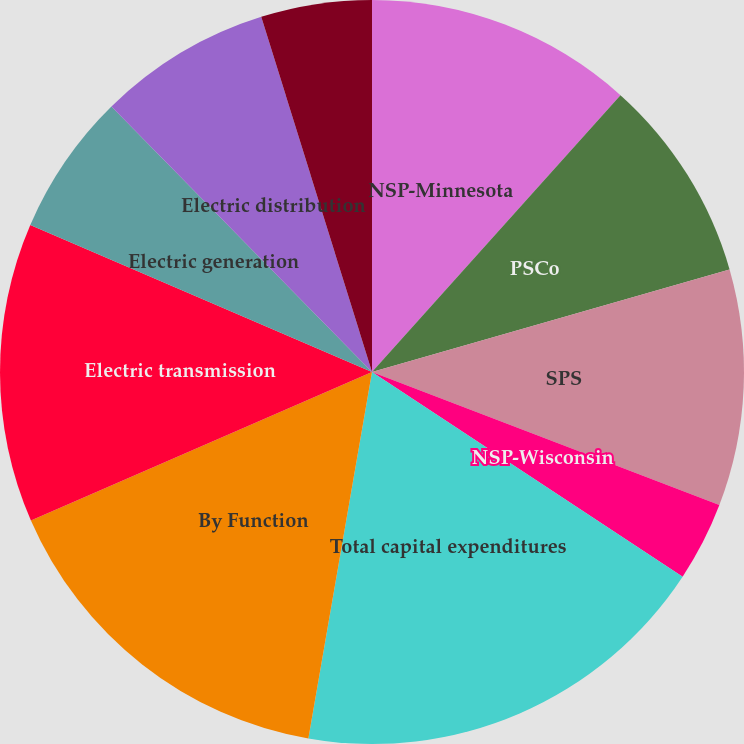<chart> <loc_0><loc_0><loc_500><loc_500><pie_chart><fcel>NSP-Minnesota<fcel>PSCo<fcel>SPS<fcel>NSP-Wisconsin<fcel>Total capital expenditures<fcel>By Function<fcel>Electric transmission<fcel>Electric generation<fcel>Electric distribution<fcel>Natural gas<nl><fcel>11.64%<fcel>8.91%<fcel>10.27%<fcel>3.45%<fcel>18.46%<fcel>15.73%<fcel>13.0%<fcel>6.18%<fcel>7.54%<fcel>4.81%<nl></chart> 